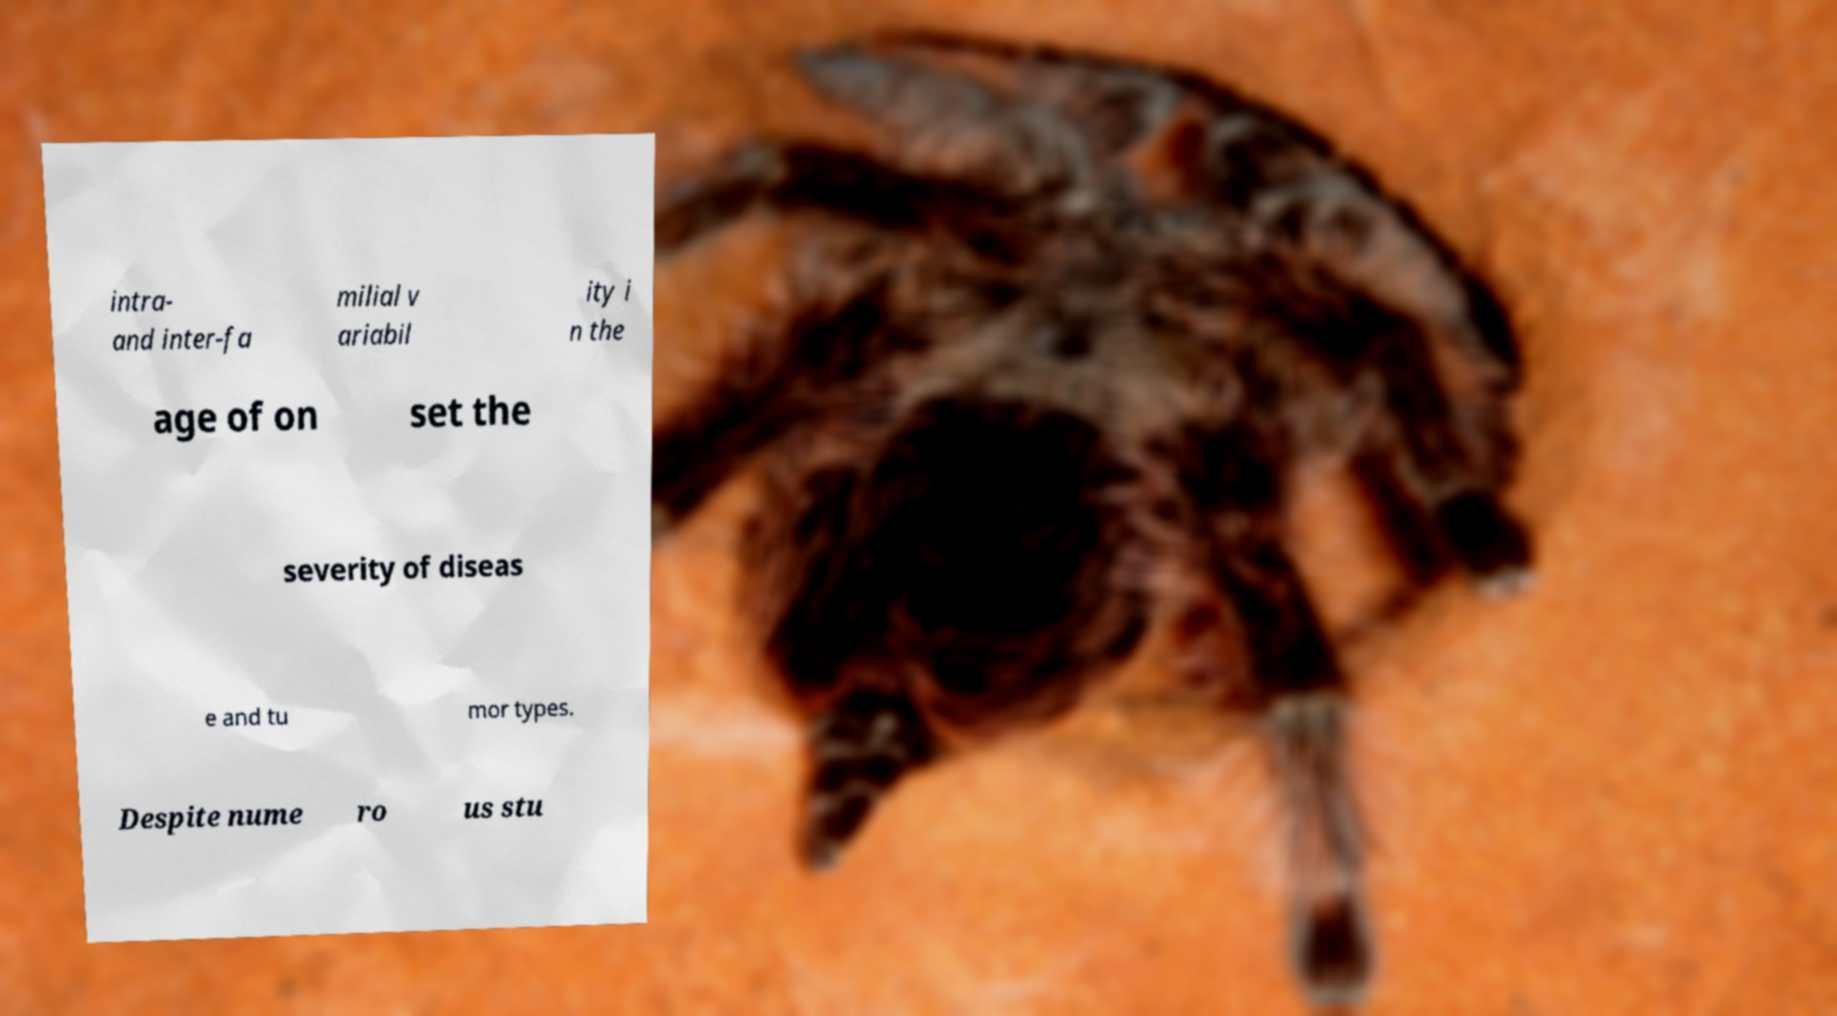For documentation purposes, I need the text within this image transcribed. Could you provide that? intra- and inter-fa milial v ariabil ity i n the age of on set the severity of diseas e and tu mor types. Despite nume ro us stu 